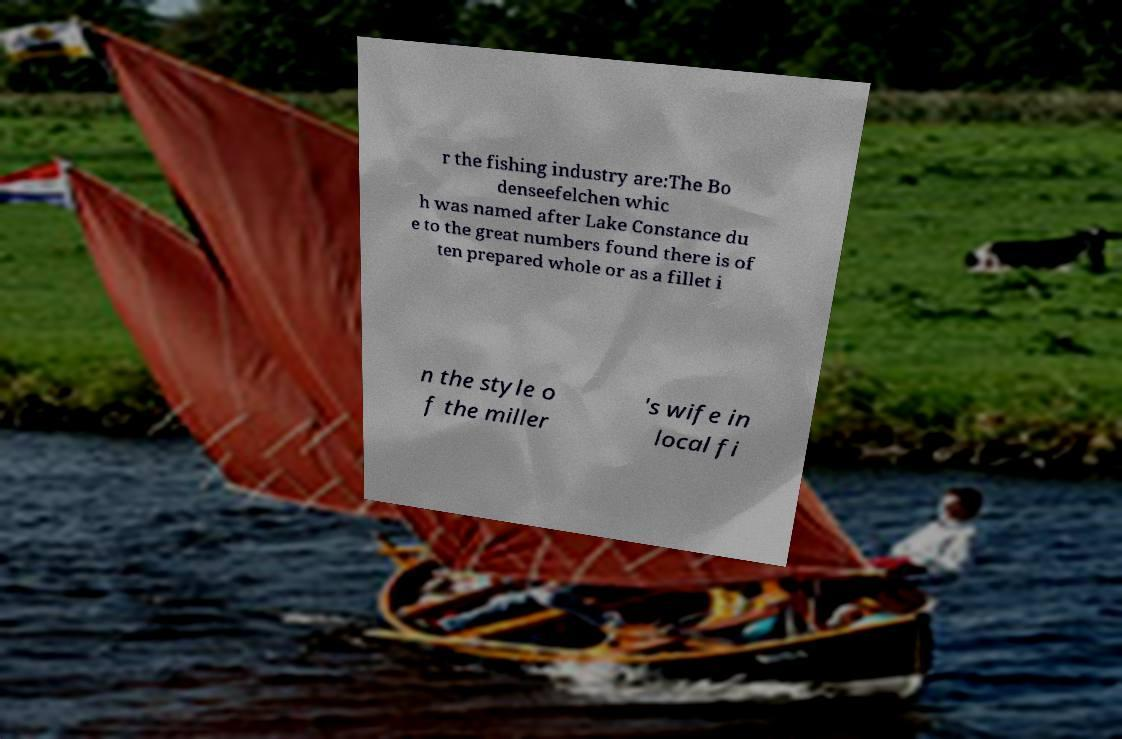For documentation purposes, I need the text within this image transcribed. Could you provide that? r the fishing industry are:The Bo denseefelchen whic h was named after Lake Constance du e to the great numbers found there is of ten prepared whole or as a fillet i n the style o f the miller 's wife in local fi 